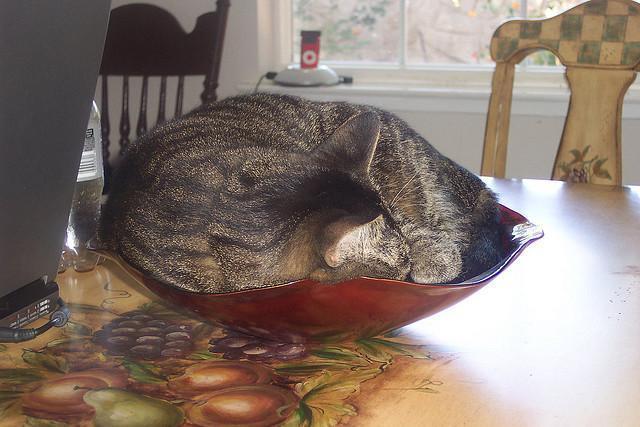How many chairs can you see?
Give a very brief answer. 2. How many girls are in the picture?
Give a very brief answer. 0. 